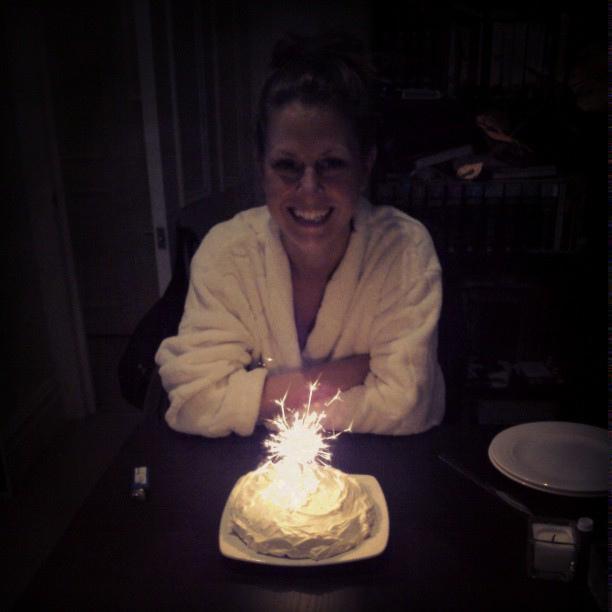How many people are there?
Give a very brief answer. 1. How many different candies are visible?
Give a very brief answer. 1. How many candles are on the cake?
Give a very brief answer. 1. How many children are beside the woman blowing out the candles?
Give a very brief answer. 0. How many candles are lit?
Give a very brief answer. 1. How many plates are there?
Give a very brief answer. 3. How many blue lanterns are hanging on the left side of the banana bunches?
Give a very brief answer. 0. 